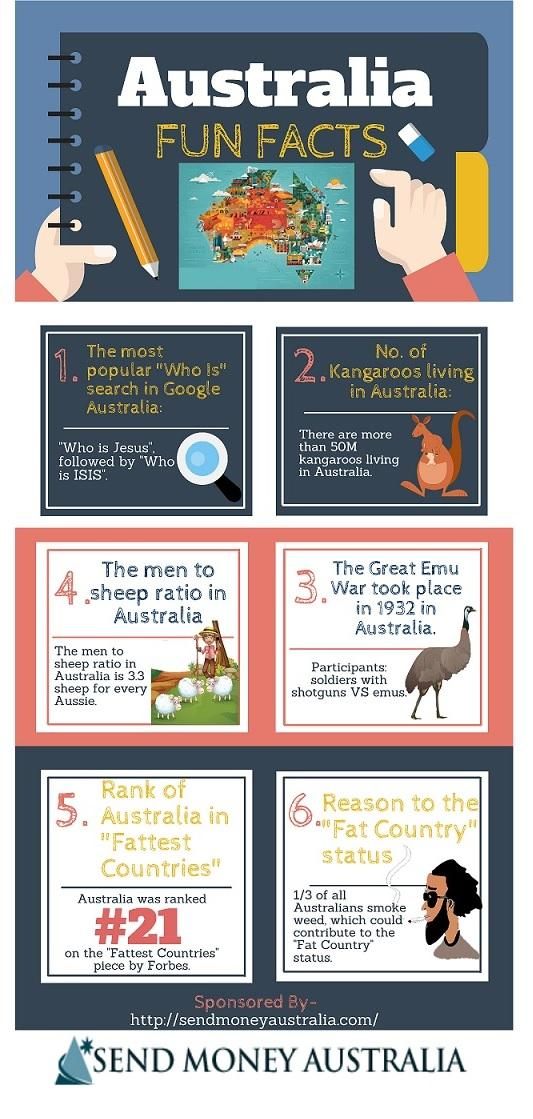Highlight a few significant elements in this photo. Out of the fun facts provided, three of them are based on animals. It is more popular to search for 'Who is Jesus' than 'Who is ISIS,' as the majority of searches indicate a preference for information about Jesus. 